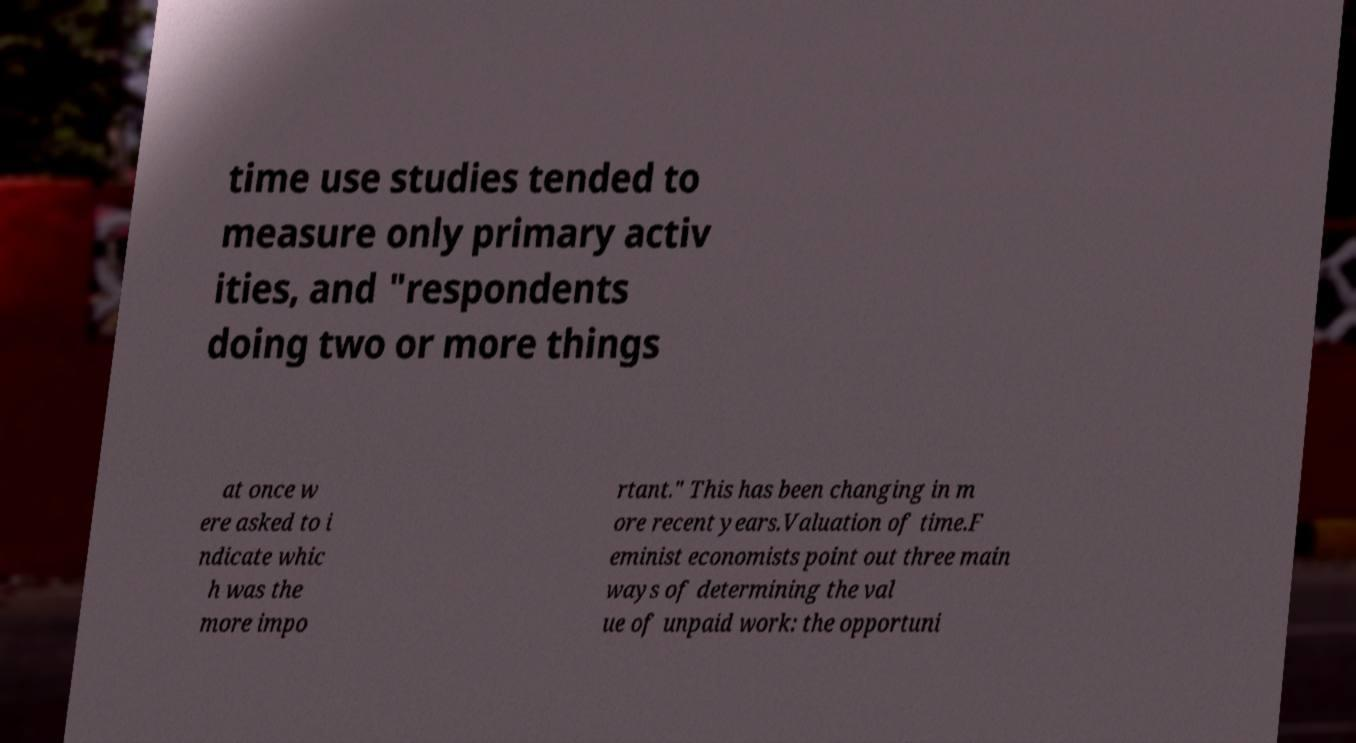What messages or text are displayed in this image? I need them in a readable, typed format. time use studies tended to measure only primary activ ities, and "respondents doing two or more things at once w ere asked to i ndicate whic h was the more impo rtant." This has been changing in m ore recent years.Valuation of time.F eminist economists point out three main ways of determining the val ue of unpaid work: the opportuni 